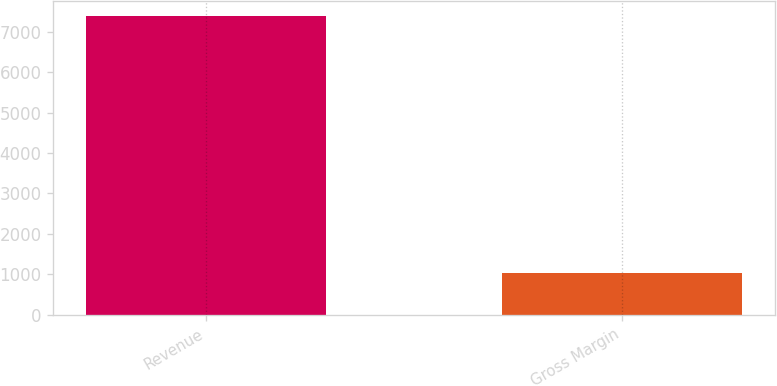Convert chart to OTSL. <chart><loc_0><loc_0><loc_500><loc_500><bar_chart><fcel>Revenue<fcel>Gross Margin<nl><fcel>7374<fcel>1035<nl></chart> 